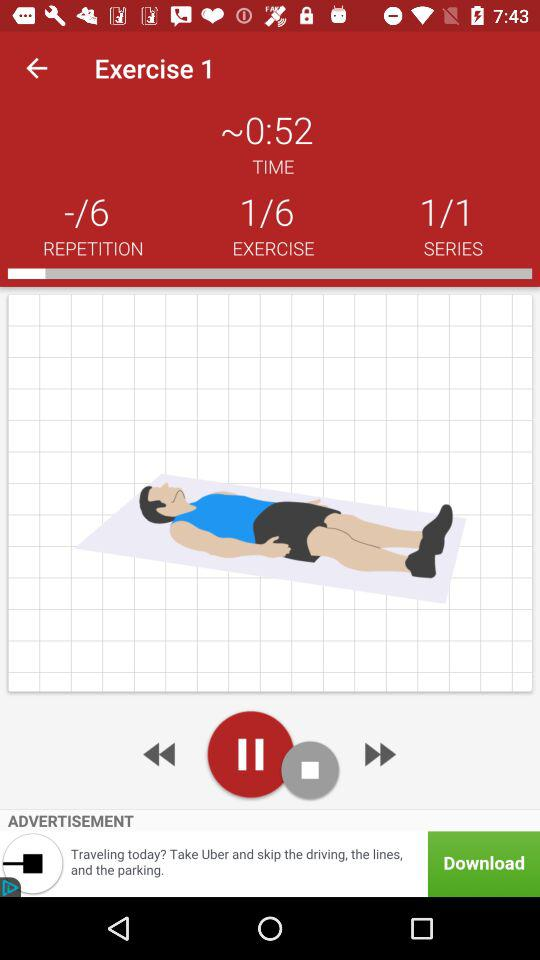What is the total number of exercises? The total number of exercises is 6. 